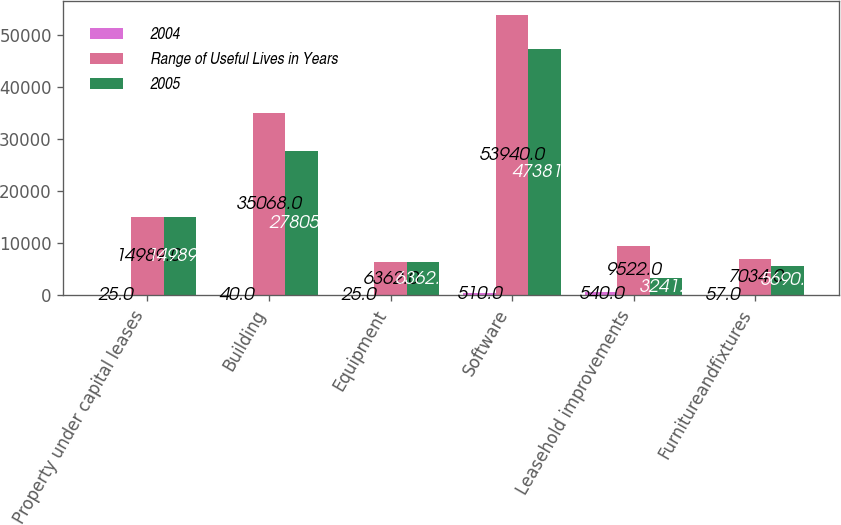Convert chart. <chart><loc_0><loc_0><loc_500><loc_500><stacked_bar_chart><ecel><fcel>Property under capital leases<fcel>Building<fcel>Equipment<fcel>Software<fcel>Leasehold improvements<fcel>Furnitureandfixtures<nl><fcel>2004<fcel>25<fcel>40<fcel>25<fcel>510<fcel>540<fcel>57<nl><fcel>Range of Useful Lives in Years<fcel>14989<fcel>35068<fcel>6362<fcel>53940<fcel>9522<fcel>7034<nl><fcel>2005<fcel>14989<fcel>27805<fcel>6362<fcel>47381<fcel>3241<fcel>5690<nl></chart> 